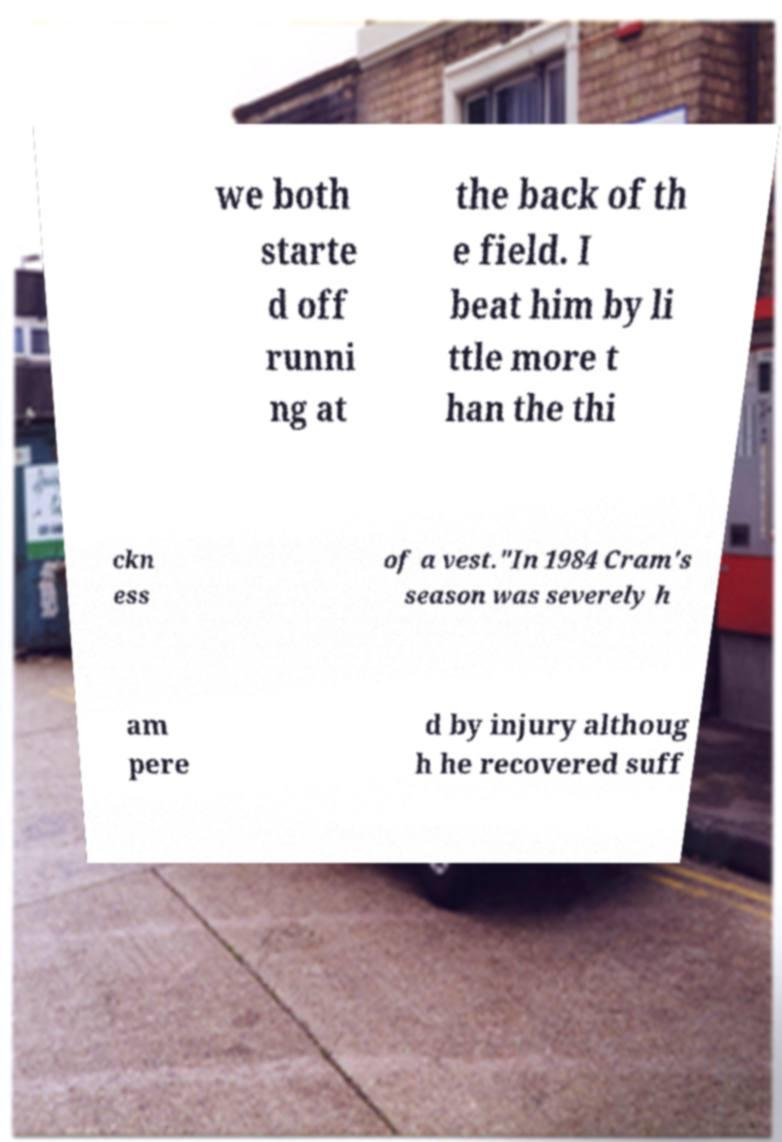Could you assist in decoding the text presented in this image and type it out clearly? we both starte d off runni ng at the back of th e field. I beat him by li ttle more t han the thi ckn ess of a vest."In 1984 Cram's season was severely h am pere d by injury althoug h he recovered suff 